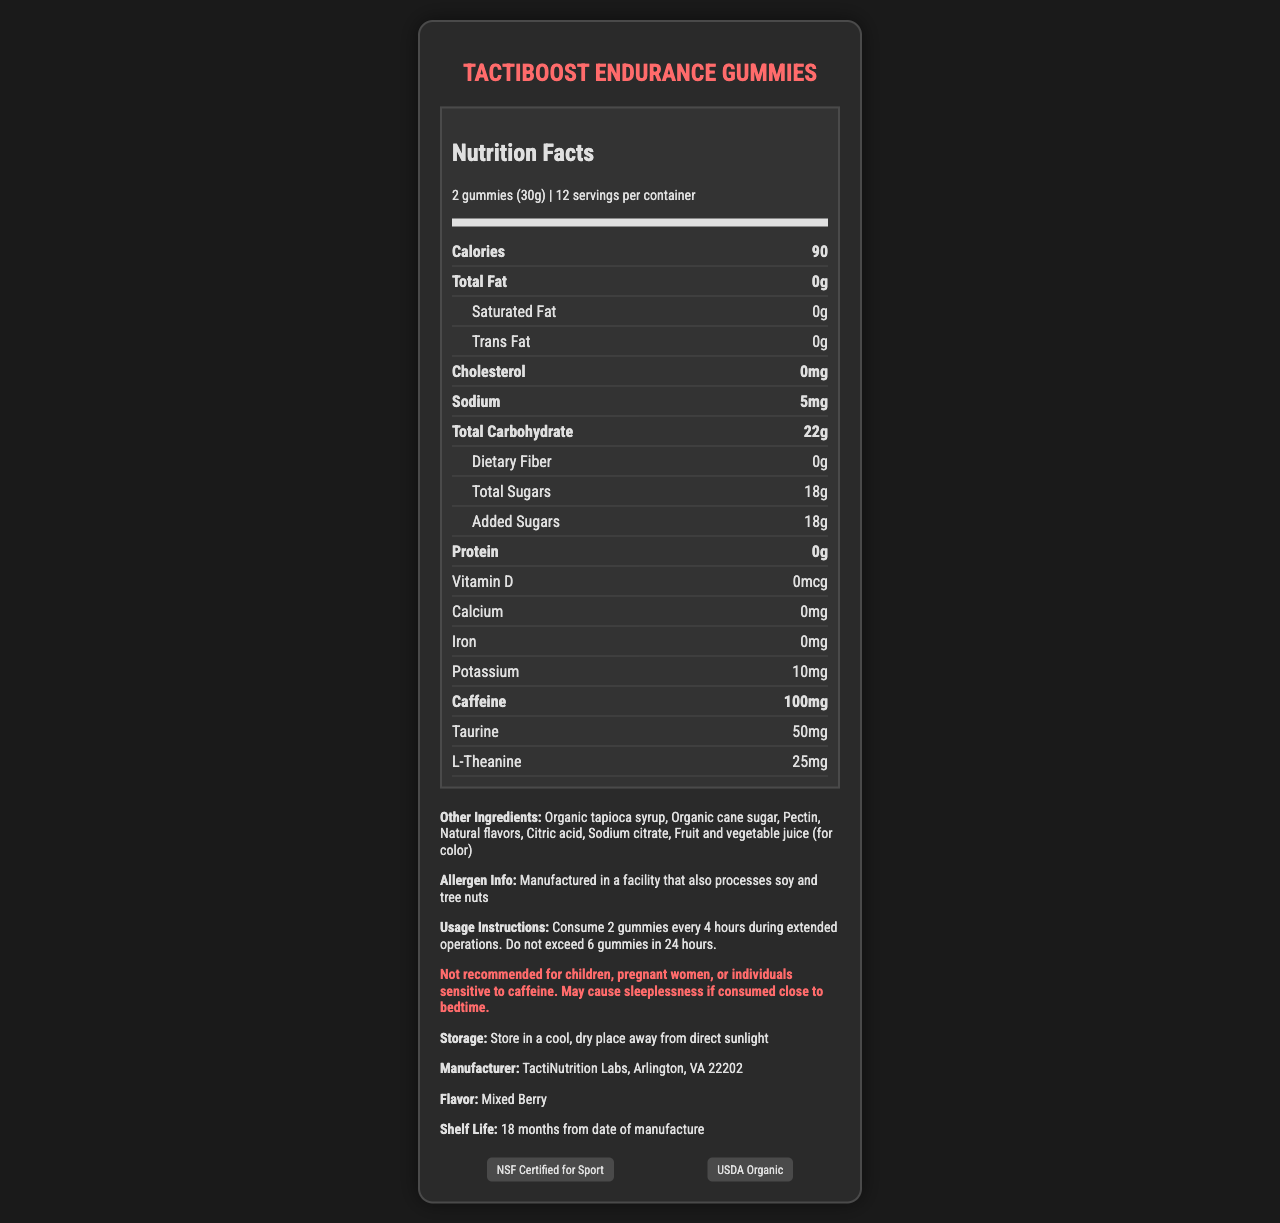what is the serving size? The serving size is listed in the “serving size” section at the top of the nutrition label.
Answer: 2 gummies (30g) how many calories are there per serving? The calories per serving are shown in a bold section labeled "Calories" in the nutrition facts.
Answer: 90 what is the recommended usage for these gummies? The recommended usage instructions are located in the additional information section under "Usage Instructions."
Answer: Consume 2 gummies every 4 hours during extended operations. Do not exceed 6 gummies in 24 hours. what ingredients are used to color these gummies? The ingredient list specifies "Fruit and vegetable juice (for color)" as the coloring agent.
Answer: Fruit and vegetable juice how much caffeine is in a single serving? The amount of caffeine in a single serving is specified in the bold section labeled "Caffeine."
Answer: 100mg which of the following vitamins are included in the supplement? A. Vitamin C B. Vitamin D C. Vitamin B6 D. Vitamin E Only Vitamin B6 is listed under the B vitamin section; neither Vitamin C, Vitamin D, nor Vitamin E is included.
Answer: C what is the amount of sodium per serving? A. 5mg B. 10mg C. 15mg D. 20mg The sodium content per serving is found in the section labeled “Sodium,” and it states 5mg.
Answer: A are these gummies suitable for individuals sensitive to caffeine? The warning section explicitly states that the product is not recommended for individuals sensitive to caffeine.
Answer: No can these gummies be eaten by children? The warning section specifies that the gummies are not recommended for children.
Answer: No summarize the main idea of the document. The summary covers the key sections and points of the document, providing a comprehensive overview of what the product is, its nutritional content, how to use it, and other relevant details.
Answer: The document provides detailed nutritional information about TactiBoost Endurance Gummies, which are caffeine-enhanced performance gummies designed for extended operations. It includes serving size, calories, breakdown of nutrients, ingredients, allergen information, usage instructions, and warnings. The product is manufactured by TactiNutrition Labs and carries certifications such as NSF Certified for Sport and USDA Organic. The flavor is Mixed Berry, and the product has a shelf life of 18 months. how many servings are there per container? The number of servings per container is displayed at the top of the nutrition facts label, under the serving size information.
Answer: 12 what is the flavor of the gummies? The flavor information is found in the additional information section under "Flavor."
Answer: Mixed Berry how long is the shelf life of this product? The shelf life is mentioned in the additional information section under "Shelf Life."
Answer: 18 months from date of manufacture can the exact manufacturing date of the gummies be found in the document? The document specifies the shelf life but does not provide the exact manufacturing date.
Answer: Not enough information what certifications does this product have? The certifications are listed in the additional information section under "Certifications."
Answer: NSF Certified for Sport, USDA Organic 